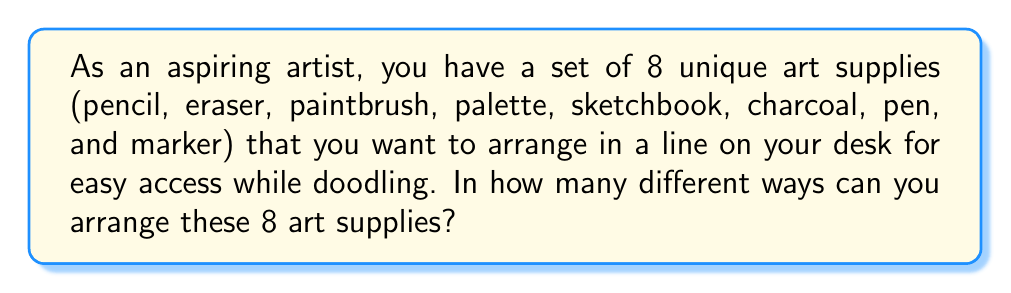Show me your answer to this math problem. To solve this problem, we need to use the concept of permutations. Since we are arranging all 8 items and the order matters (each arrangement is considered unique), this is a straightforward application of the permutation formula.

The number of permutations of n distinct objects is given by:

$$P(n) = n!$$

Where $n!$ (n factorial) is the product of all positive integers less than or equal to n.

In this case, we have 8 distinct art supplies, so $n = 8$.

Therefore, the number of unique arrangements is:

$$P(8) = 8!$$

Let's calculate this:

$$\begin{align}
8! &= 8 \times 7 \times 6 \times 5 \times 4 \times 3 \times 2 \times 1 \\
   &= 40,320
\end{align}$$

This means there are 40,320 different ways to arrange your 8 art supplies on your desk.
Answer: $40,320$ 